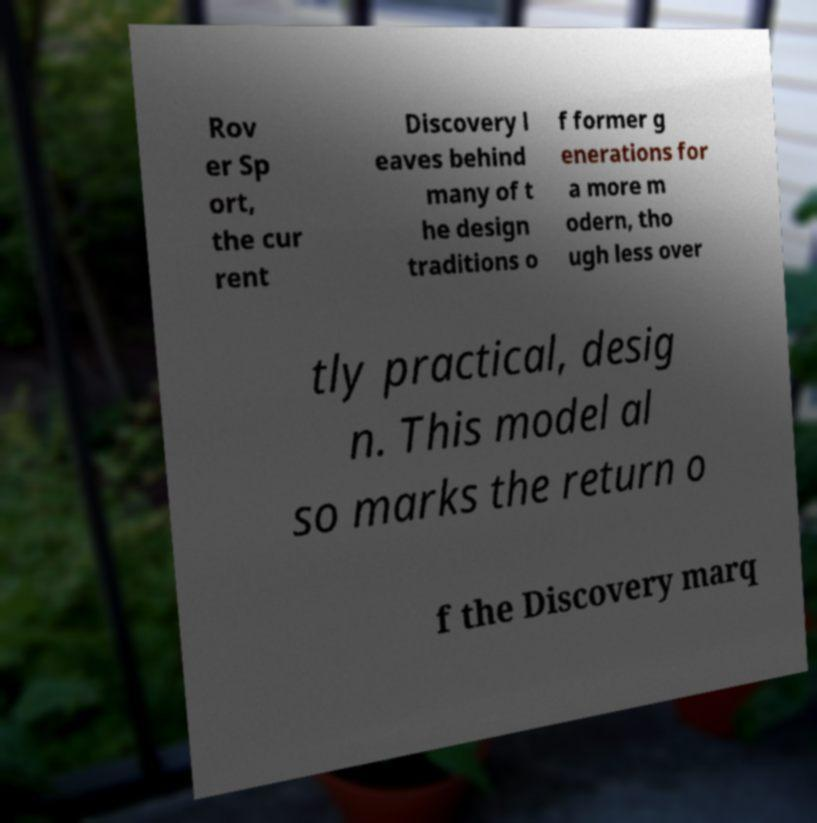Please read and relay the text visible in this image. What does it say? Rov er Sp ort, the cur rent Discovery l eaves behind many of t he design traditions o f former g enerations for a more m odern, tho ugh less over tly practical, desig n. This model al so marks the return o f the Discovery marq 